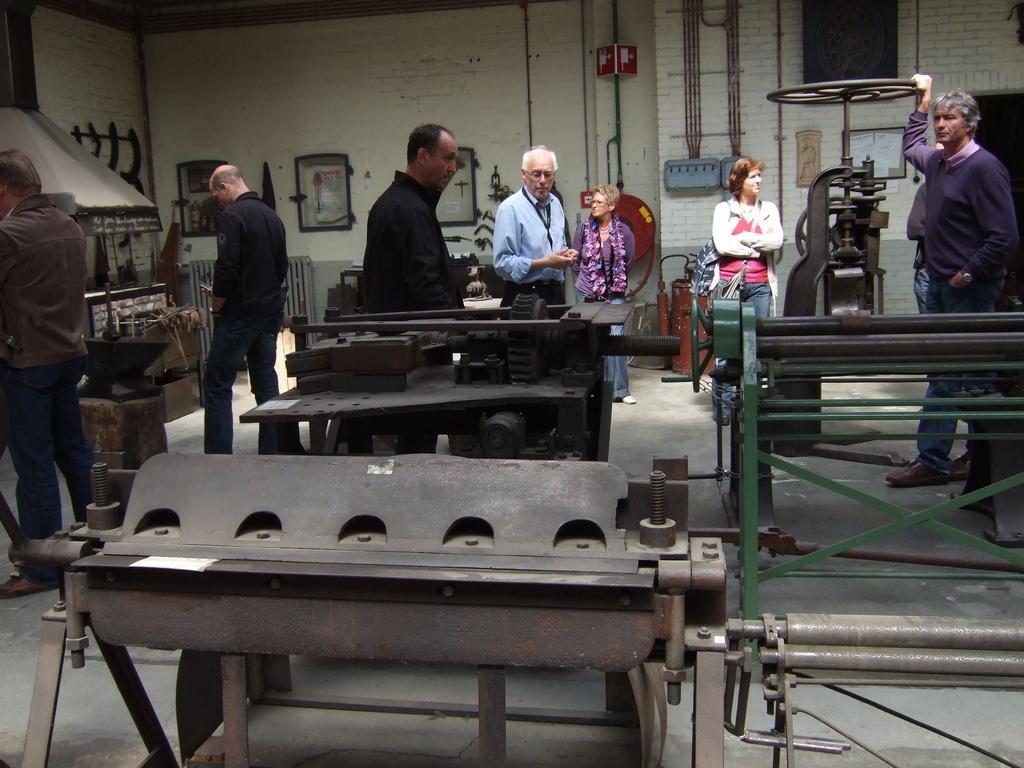Can you describe this image briefly? This picture shows a few people standing and we see a man standing and holding a machine wheel and we see few machines and couple of photo frames on the wall. 